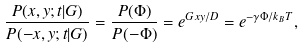<formula> <loc_0><loc_0><loc_500><loc_500>\frac { P ( x , y ; t | G ) } { P ( - x , y ; t | G ) } = \frac { P ( \Phi ) } { P ( - \Phi ) } = e ^ { G x y / D } = e ^ { - \gamma \Phi / k _ { B } T } ,</formula> 